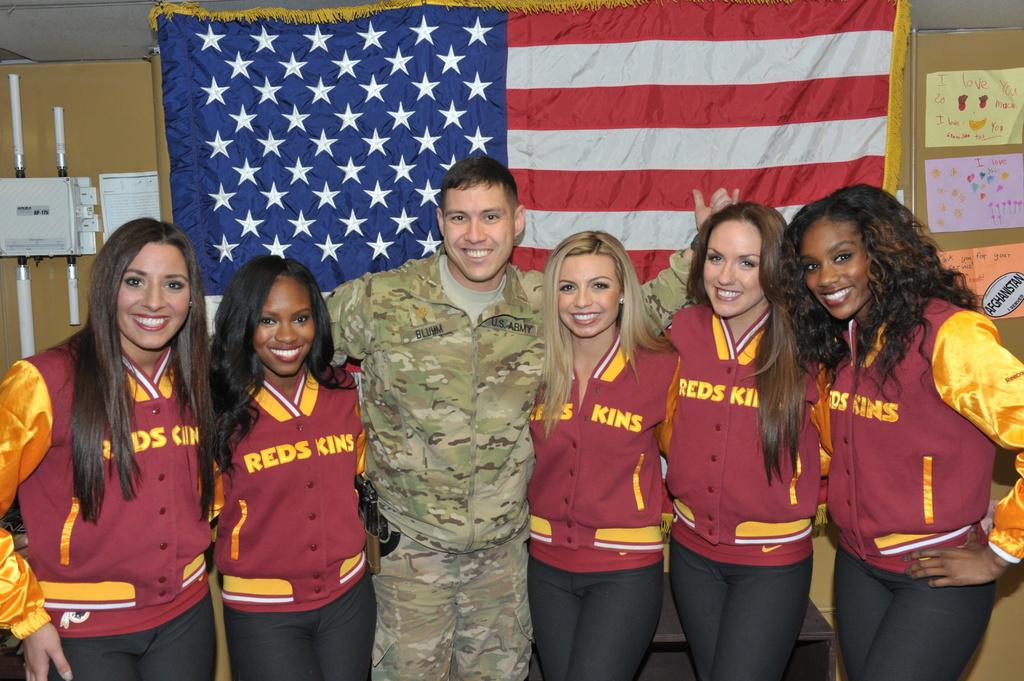<image>
Summarize the visual content of the image. A group of women wearing the jackets with the word redskins on them standing before a flag with a soldier. 